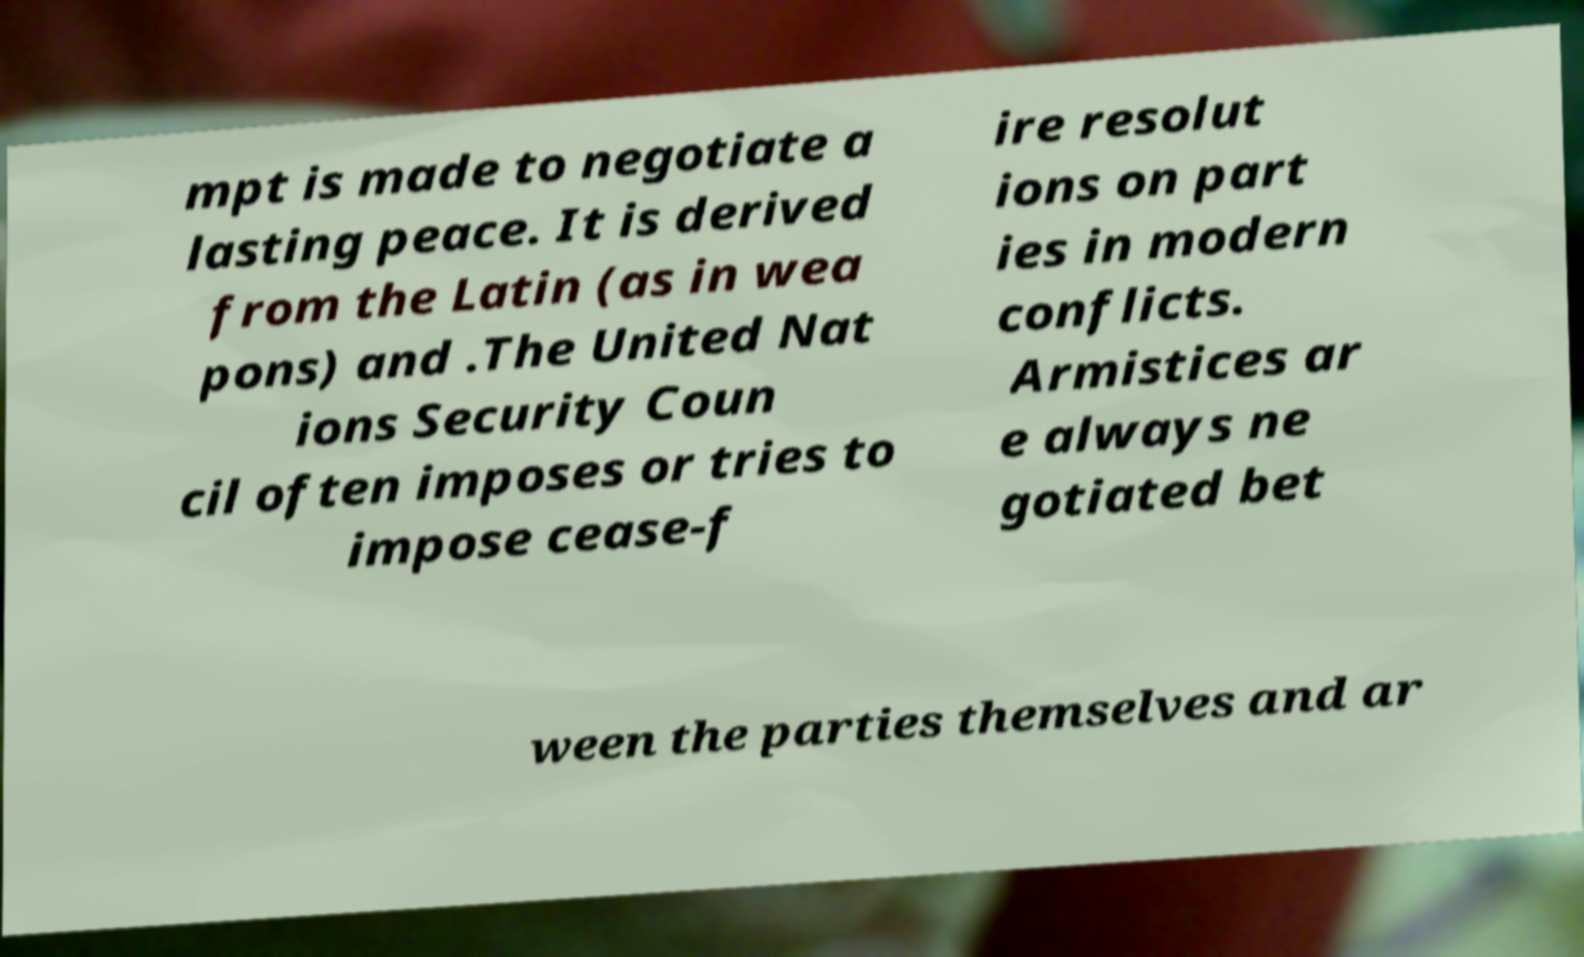What messages or text are displayed in this image? I need them in a readable, typed format. mpt is made to negotiate a lasting peace. It is derived from the Latin (as in wea pons) and .The United Nat ions Security Coun cil often imposes or tries to impose cease-f ire resolut ions on part ies in modern conflicts. Armistices ar e always ne gotiated bet ween the parties themselves and ar 